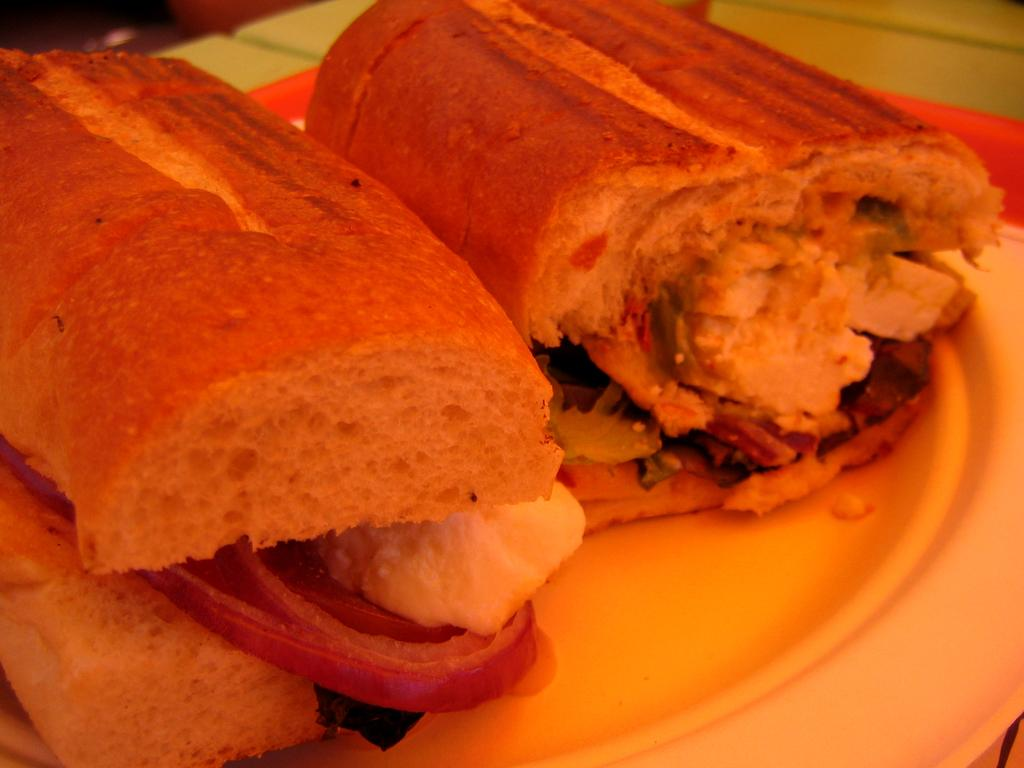What is present on the plate in the image? There is an item on the plate in the image. What type of crime is being committed in the image? There is no crime being committed in the image; it only features a plate with an item on it. What time of day is depicted in the image? The time of day is not specified in the image, so it cannot be determined from the image alone. 